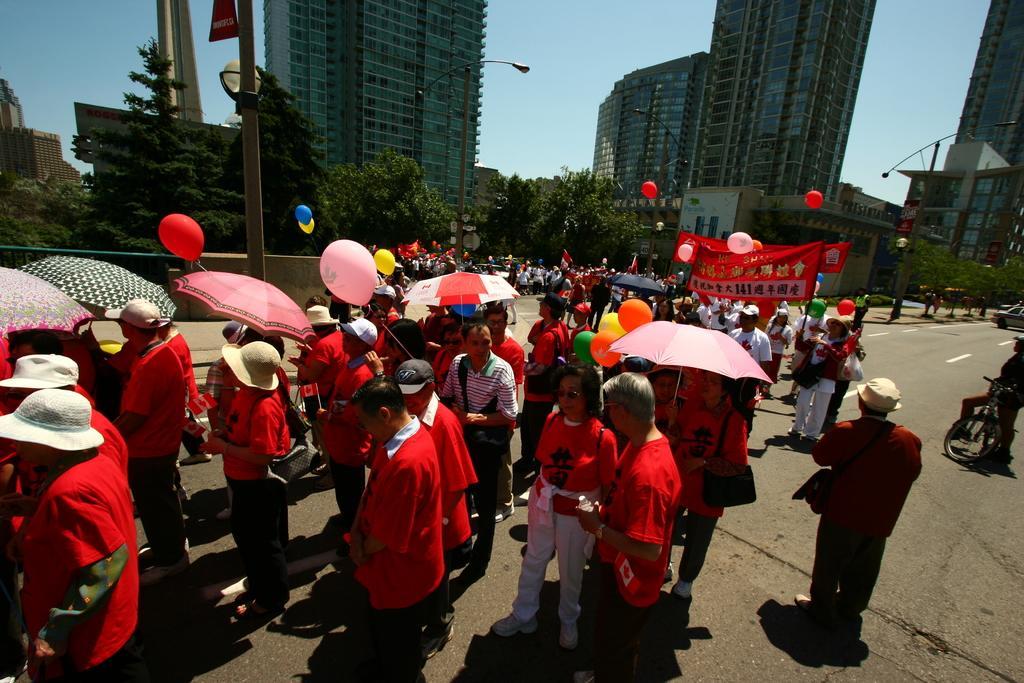Please provide a concise description of this image. There are many people. Some are holding balloons and umbrellas. Some are wearing caps and hats. There is a road. And there is a banner. In the back there are trees, buildings, street light poles and sky.. 